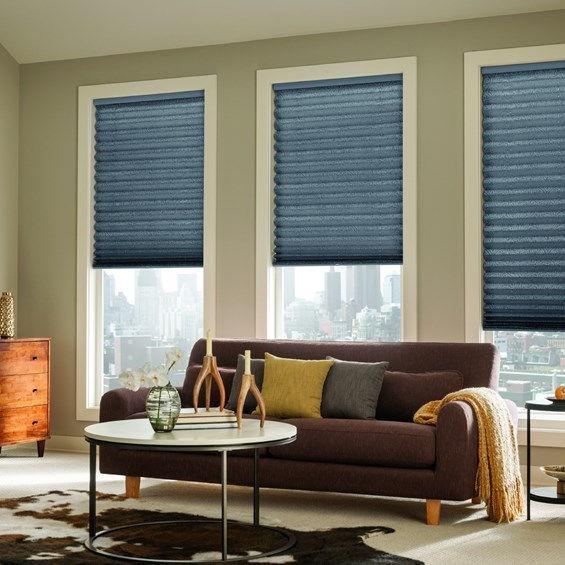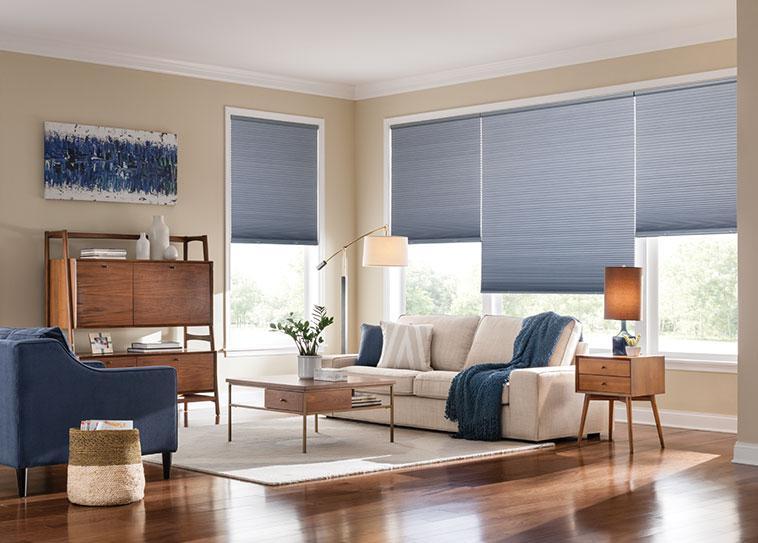The first image is the image on the left, the second image is the image on the right. For the images shown, is this caption "The left image shows one shade with a straight bottom hanging in front of, but not fully covering, a white paned window." true? Answer yes or no. No. The first image is the image on the left, the second image is the image on the right. For the images shown, is this caption "There is one solid blue chair/couch visible." true? Answer yes or no. Yes. 